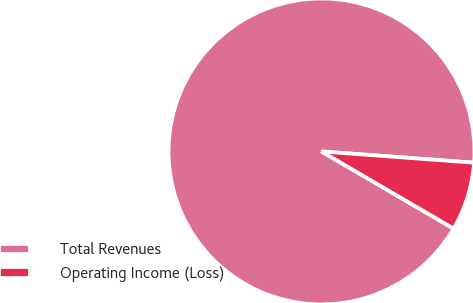<chart> <loc_0><loc_0><loc_500><loc_500><pie_chart><fcel>Total Revenues<fcel>Operating Income (Loss)<nl><fcel>92.76%<fcel>7.24%<nl></chart> 